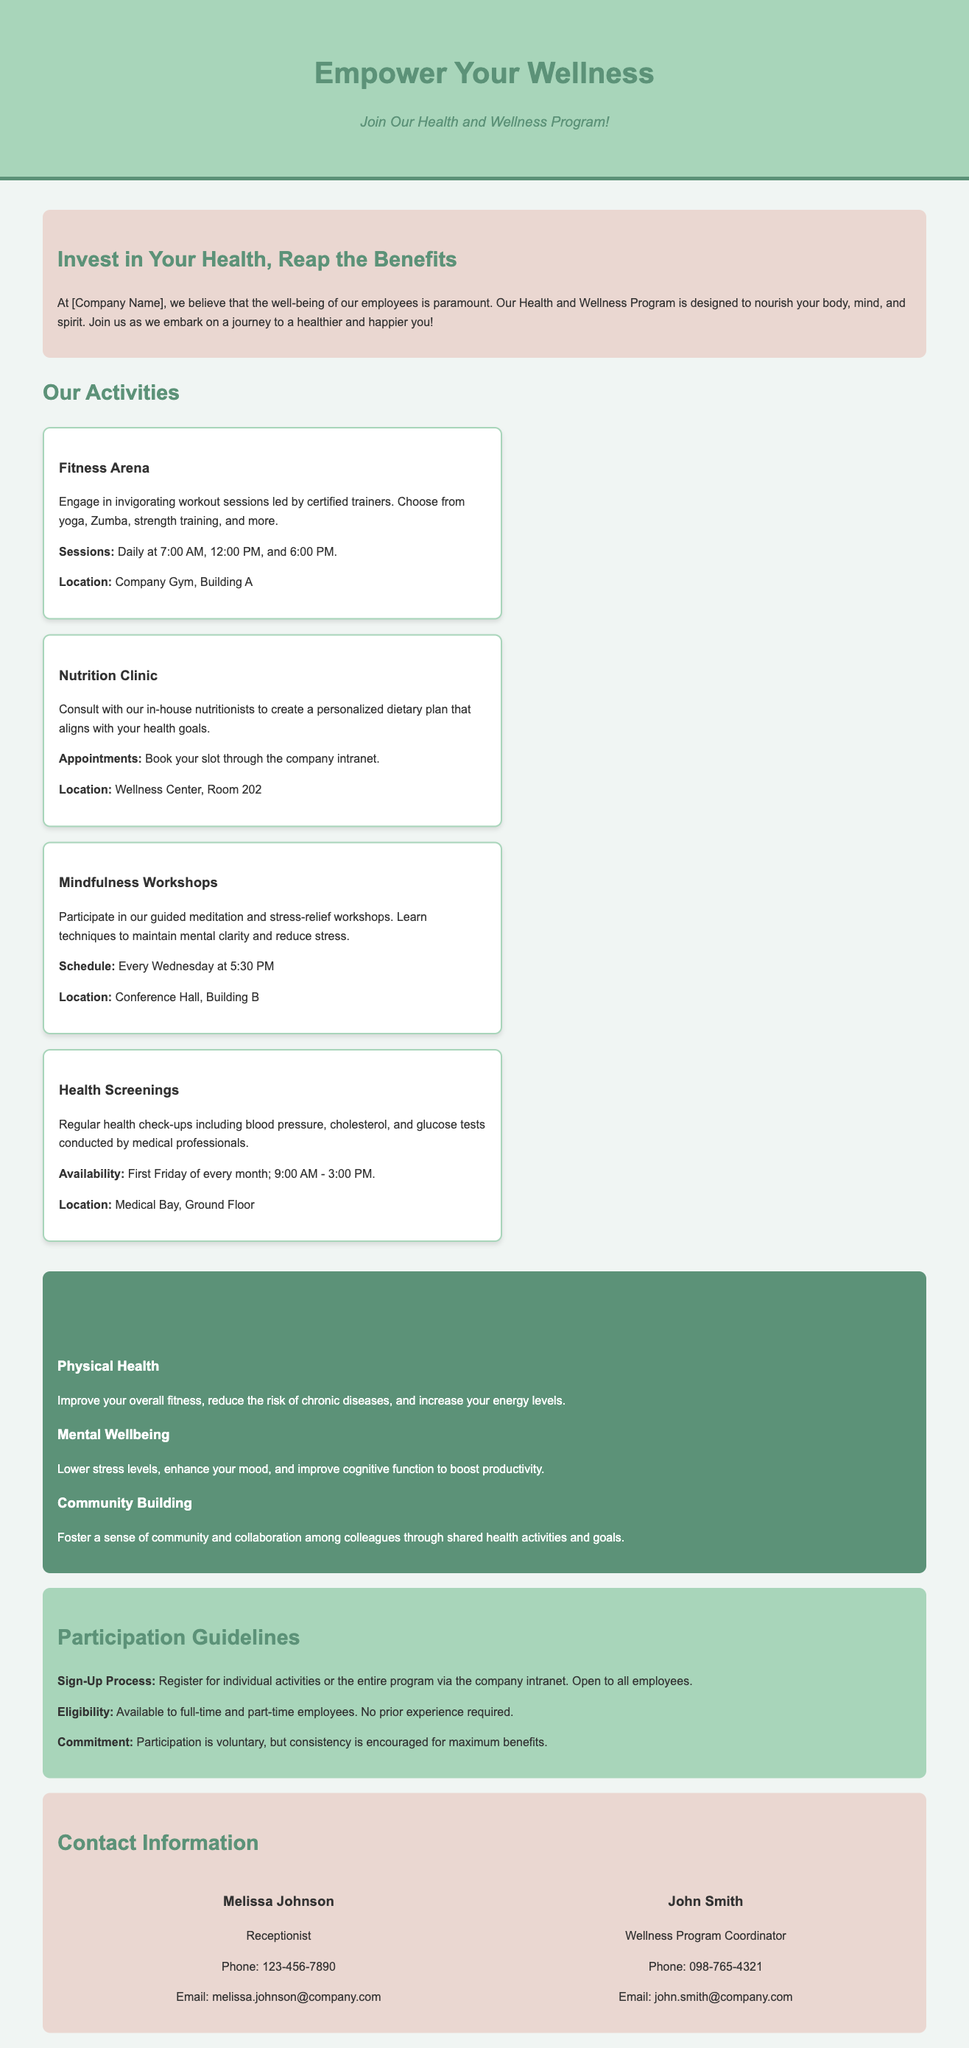What is the title of the program? The title of the program is prominently displayed at the top of the document as "Empower Your Wellness."
Answer: Empower Your Wellness Who is the contact person for the wellness program? The contact person for the wellness program is mentioned in the contact section of the document.
Answer: John Smith How often are fitness sessions held? The fitness sessions schedule provided in the document states their frequency.
Answer: Daily What activity is scheduled every Wednesday? The document outlines various activities, indicating that one occurs specifically on Wednesdays.
Answer: Mindfulness Workshops What is the phone number for the receptionist? The phone number for the receptionist is listed in the contact section of the document.
Answer: 123-456-7890 What is one of the benefits regarding mental wellbeing? The document details several benefits, particularly focusing on mental wellbeing.
Answer: Lower stress levels What do employees need to do to register for the program? The registration process is outlined in the participation guidelines of the document.
Answer: Register via the company intranet What is the location for health screenings? The location for health screenings is specified in the activities section of the document.
Answer: Medical Bay, Ground Floor 